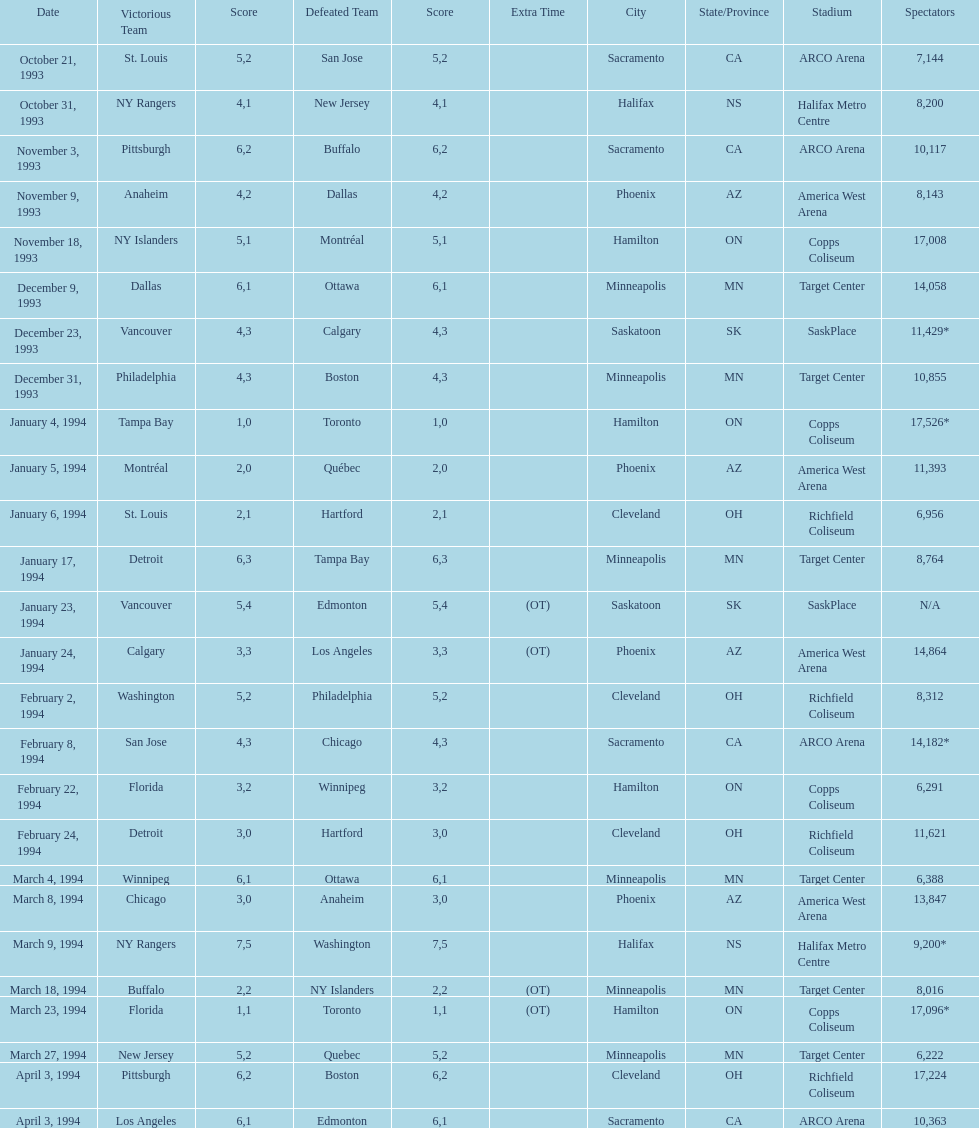Which event had higher attendance, january 24, 1994, or december 23, 1993? January 4, 1994. 